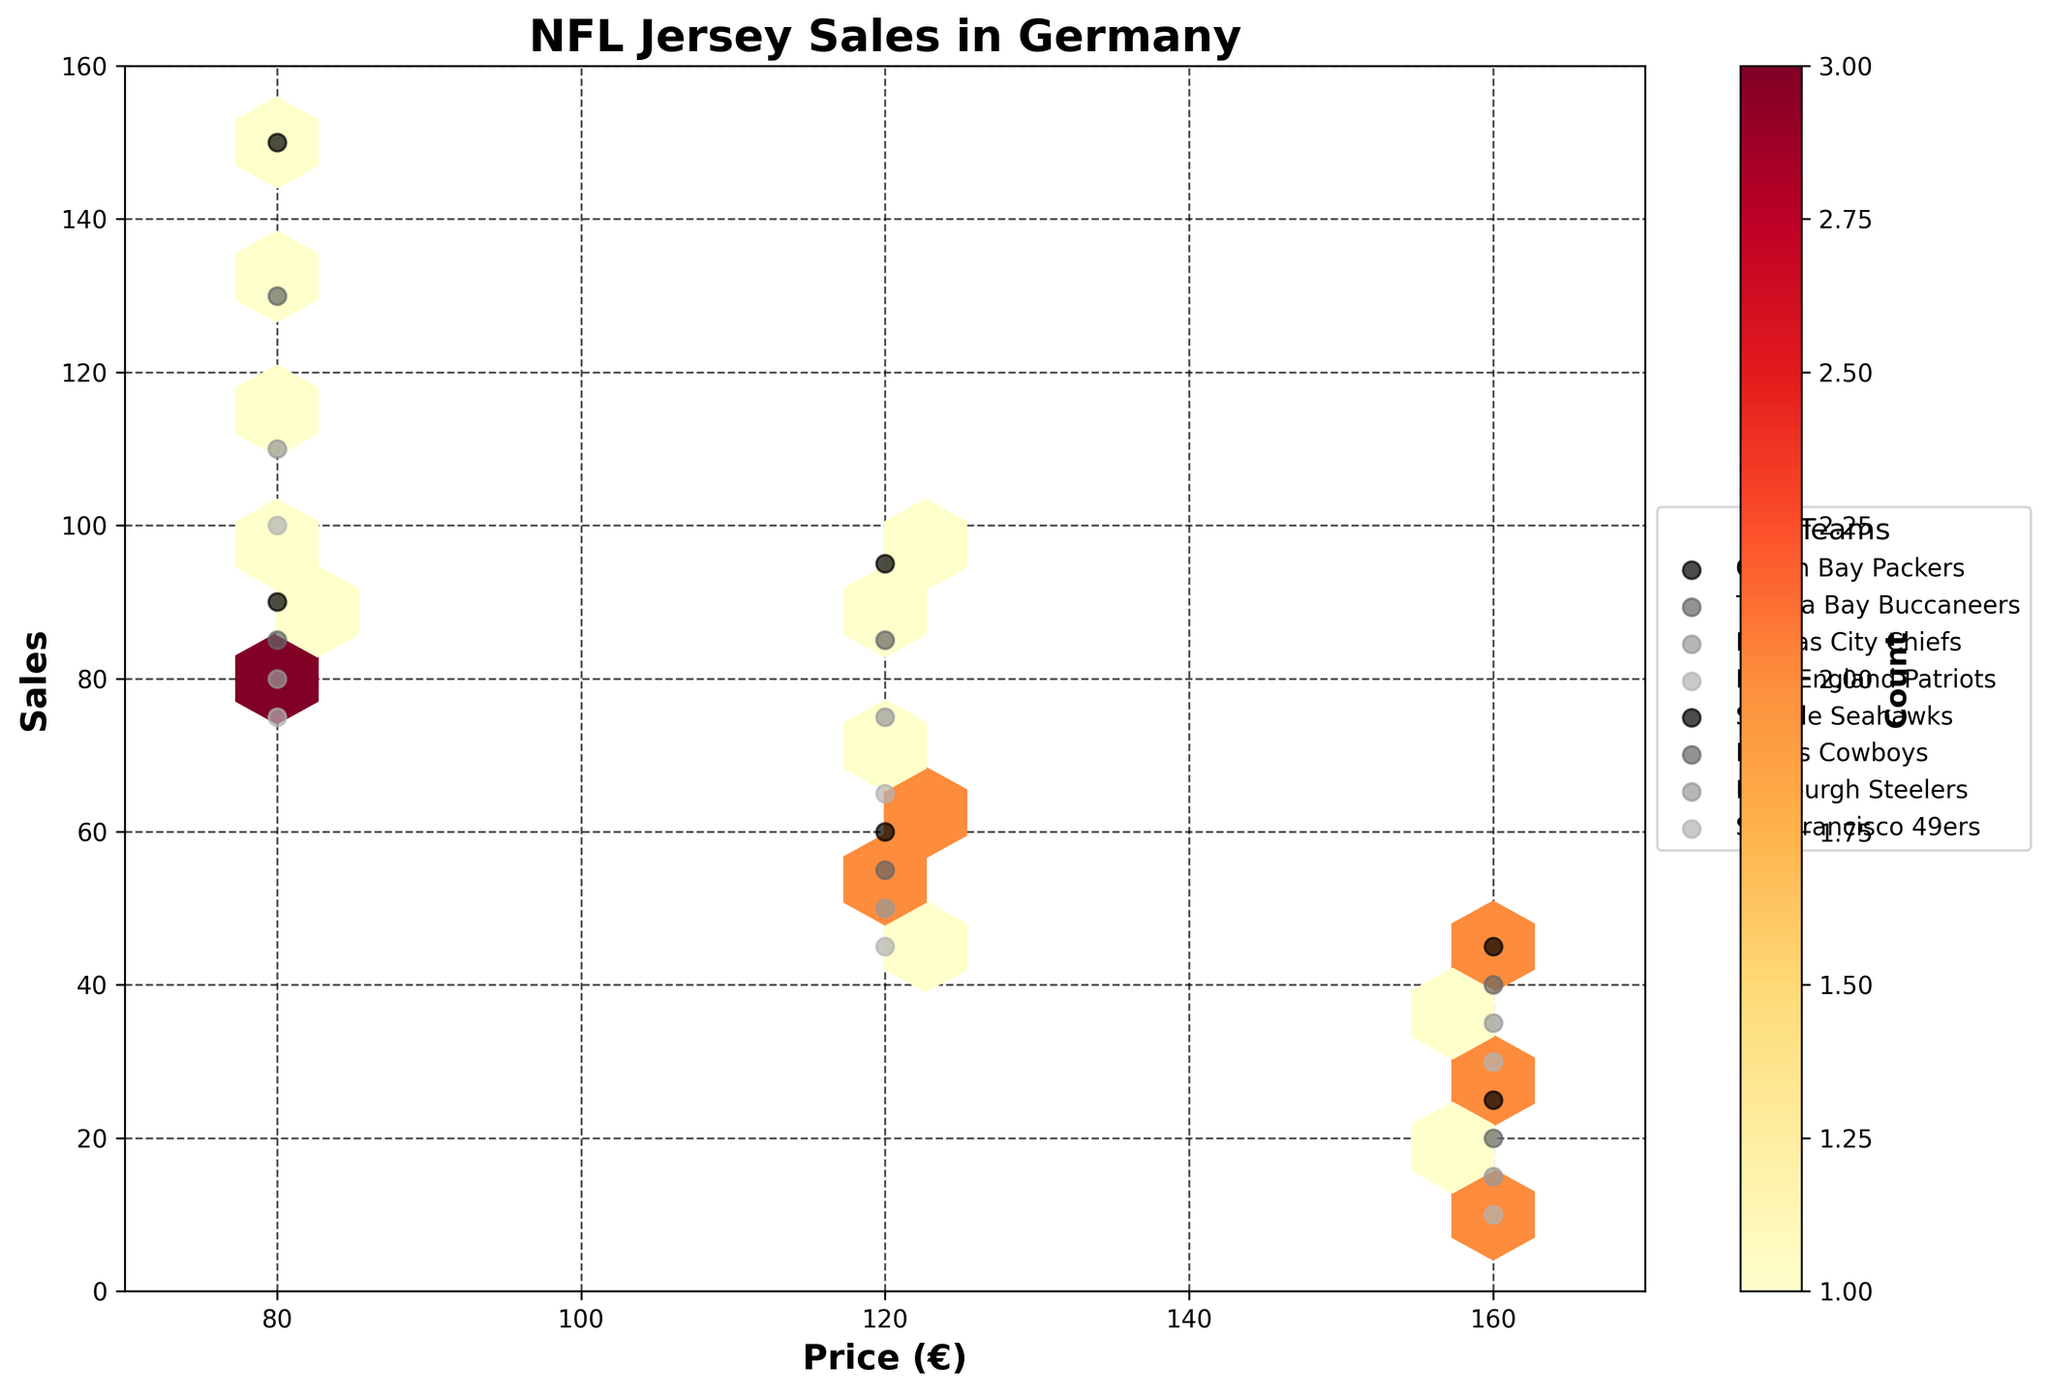What's the title of the plot? The title of the plot is displayed at the top center of the figure. It reads "NFL Jersey Sales in Germany".
Answer: NFL Jersey Sales in Germany Which NFL team appears to have the highest sales count overall? By visually inspecting the density and scatter points, the Green Bay Packers have the highest individual sales points, especially around the price of €80. Their hexbin density is also prominent.
Answer: Green Bay Packers What is the range of prices shown on the x-axis? By looking at the x-axis labels, the price range starts at €70 and ends at €170.
Answer: €70 - €170 Which price point shows the highest density of sales, and around which sales value? By analyzing the hexbin density, the price point €80 shows the highest density, with sales concentrated around 150.
Answer: €80 around 150 sales How are the sales for the price range €160 spread across different teams? The sales for the price range of €160 are spread sparsely among all teams, with the highest sales around 45 for the Green Bay Packers and the lowest at 10 for the San Francisco 49ers. This is observed from the scatter points at this price level.
Answer: Between 10 and 45 Which team has the least sales at the €120 price point? By analyzing the scatter points for €120, the San Francisco 49ers have the lowest sales at 45.
Answer: San Francisco 49ers Comparing the €80 and €120 price points, which one generally has higher sales values across the teams? Observing the hexbin density and scatter points, the €80 price point generally shows higher sales values across all the teams compared to €120.
Answer: €80 What can be inferred about the sales trend as price increases by referring to the scatter points? As the price increases from €80 to €160, the scatter points show a downward trend in sales for all teams, indicating fewer sales as prices go up.
Answer: Decreases How many teams have been included in the hexbin plot? By looking at the legend on the plot, there are 8 different teams included in the plot.
Answer: 8 What does the color intensity in the hexbin plot represent? The color intensity in the hexbin plot, indicated by the colorbar, represents the count of sales within each hexbin. Brighter colors denote higher counts.
Answer: Count of sales 